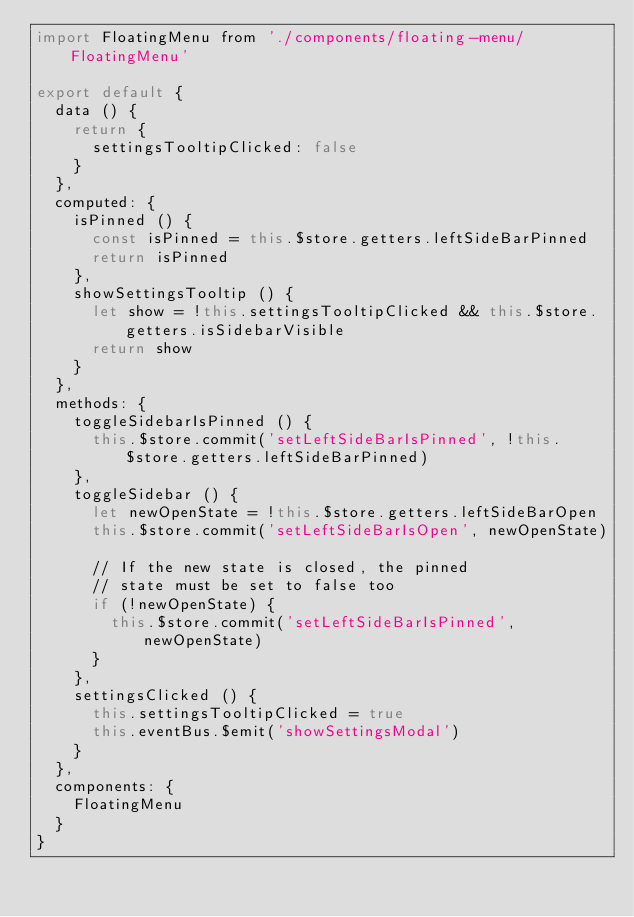Convert code to text. <code><loc_0><loc_0><loc_500><loc_500><_JavaScript_>import FloatingMenu from './components/floating-menu/FloatingMenu'

export default {
  data () {
    return {
      settingsTooltipClicked: false
    }
  },
  computed: {
    isPinned () {
      const isPinned = this.$store.getters.leftSideBarPinned
      return isPinned
    },
    showSettingsTooltip () {
      let show = !this.settingsTooltipClicked && this.$store.getters.isSidebarVisible
      return show
    }
  },
  methods: {
    toggleSidebarIsPinned () {
      this.$store.commit('setLeftSideBarIsPinned', !this.$store.getters.leftSideBarPinned)
    },
    toggleSidebar () {
      let newOpenState = !this.$store.getters.leftSideBarOpen
      this.$store.commit('setLeftSideBarIsOpen', newOpenState)
      
      // If the new state is closed, the pinned 
      // state must be set to false too
      if (!newOpenState) {
        this.$store.commit('setLeftSideBarIsPinned', newOpenState)
      }
    },
    settingsClicked () {
      this.settingsTooltipClicked = true
      this.eventBus.$emit('showSettingsModal')
    }
  },
  components: {
    FloatingMenu
  }
}
</code> 